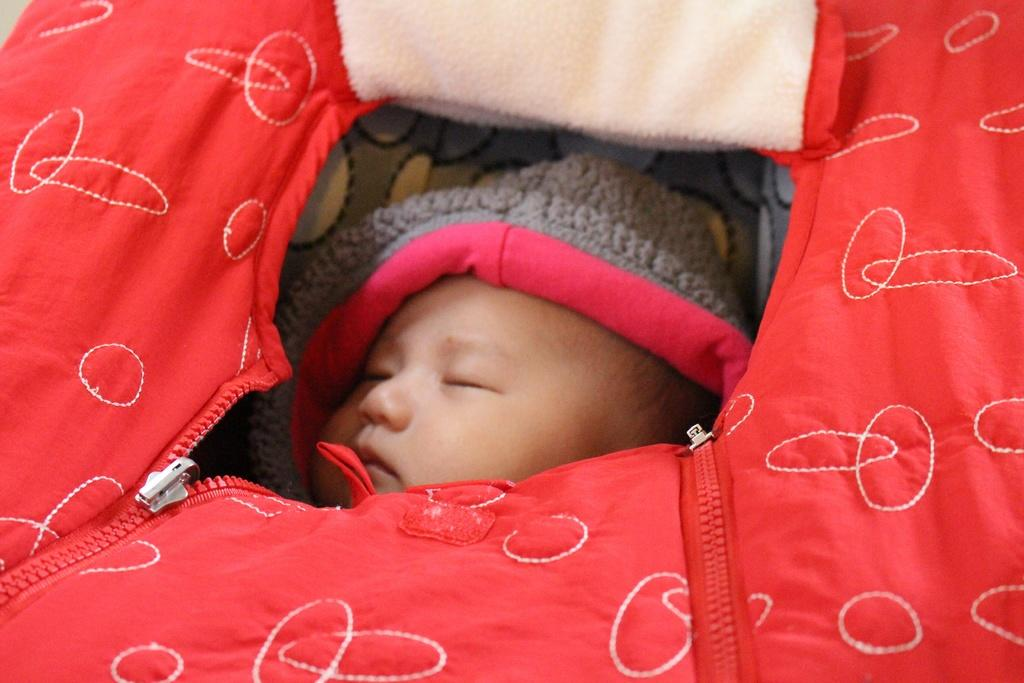What is the main subject in the foreground of the picture? There is a baby in the foreground of the picture. What is the baby placed in? The baby is in a red-colored baby cart. What type of car is the baby driving in the picture? There is no car present in the picture; the baby is in a red-colored baby cart. 